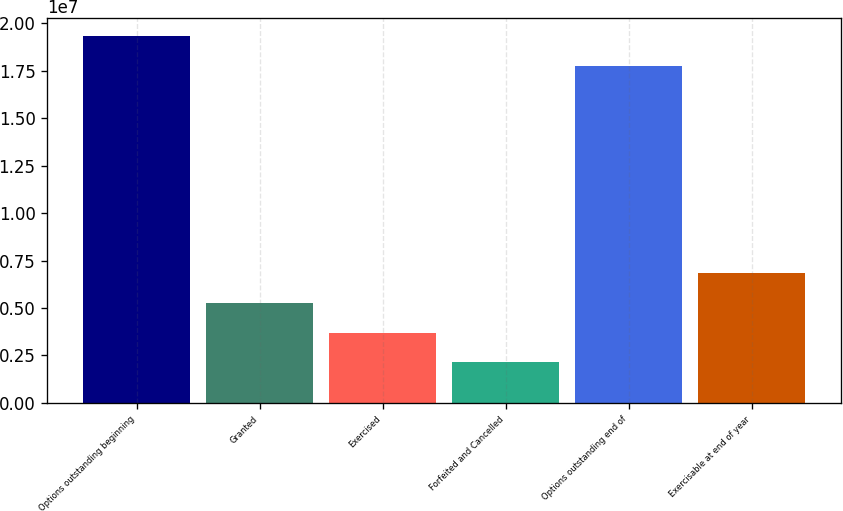Convert chart. <chart><loc_0><loc_0><loc_500><loc_500><bar_chart><fcel>Options outstanding beginning<fcel>Granted<fcel>Exercised<fcel>Forfeited and Cancelled<fcel>Options outstanding end of<fcel>Exercisable at end of year<nl><fcel>1.93021e+07<fcel>5.27585e+06<fcel>3.70798e+06<fcel>2.1401e+06<fcel>1.77342e+07<fcel>6.84372e+06<nl></chart> 